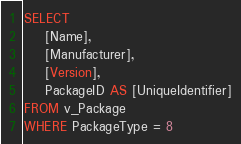Convert code to text. <code><loc_0><loc_0><loc_500><loc_500><_SQL_>SELECT 
	[Name], 
	[Manufacturer], 
	[Version], 
	PackageID AS [UniqueIdentifier]
FROM v_Package   
WHERE PackageType = 8</code> 